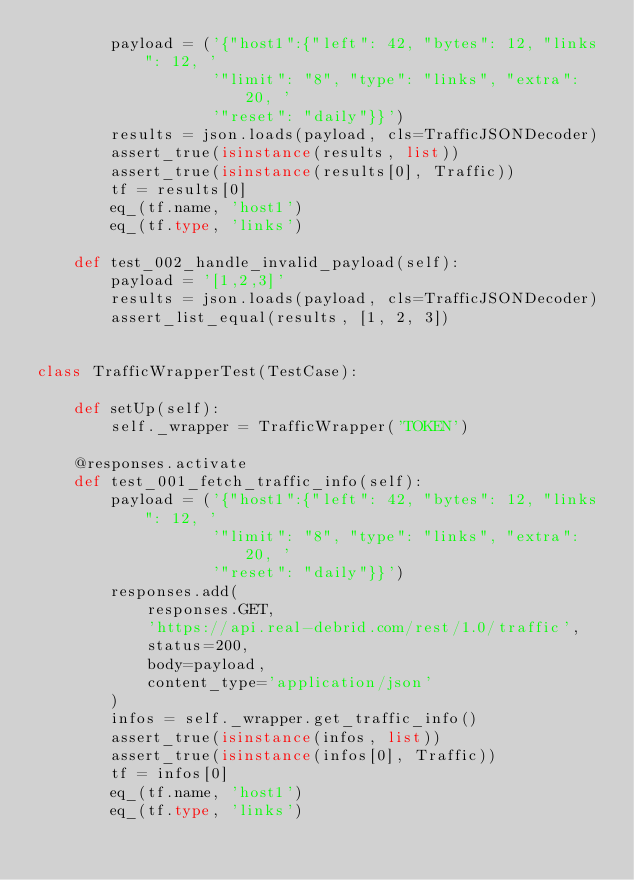<code> <loc_0><loc_0><loc_500><loc_500><_Python_>        payload = ('{"host1":{"left": 42, "bytes": 12, "links": 12, '
                   '"limit": "8", "type": "links", "extra": 20, '
                   '"reset": "daily"}}')
        results = json.loads(payload, cls=TrafficJSONDecoder)
        assert_true(isinstance(results, list))
        assert_true(isinstance(results[0], Traffic))
        tf = results[0]
        eq_(tf.name, 'host1')
        eq_(tf.type, 'links')

    def test_002_handle_invalid_payload(self):
        payload = '[1,2,3]'
        results = json.loads(payload, cls=TrafficJSONDecoder)
        assert_list_equal(results, [1, 2, 3])


class TrafficWrapperTest(TestCase):

    def setUp(self):
        self._wrapper = TrafficWrapper('TOKEN')

    @responses.activate
    def test_001_fetch_traffic_info(self):
        payload = ('{"host1":{"left": 42, "bytes": 12, "links": 12, '
                   '"limit": "8", "type": "links", "extra": 20, '
                   '"reset": "daily"}}')
        responses.add(
            responses.GET,
            'https://api.real-debrid.com/rest/1.0/traffic',
            status=200,
            body=payload,
            content_type='application/json'
        )
        infos = self._wrapper.get_traffic_info()
        assert_true(isinstance(infos, list))
        assert_true(isinstance(infos[0], Traffic))
        tf = infos[0]
        eq_(tf.name, 'host1')
        eq_(tf.type, 'links')
</code> 